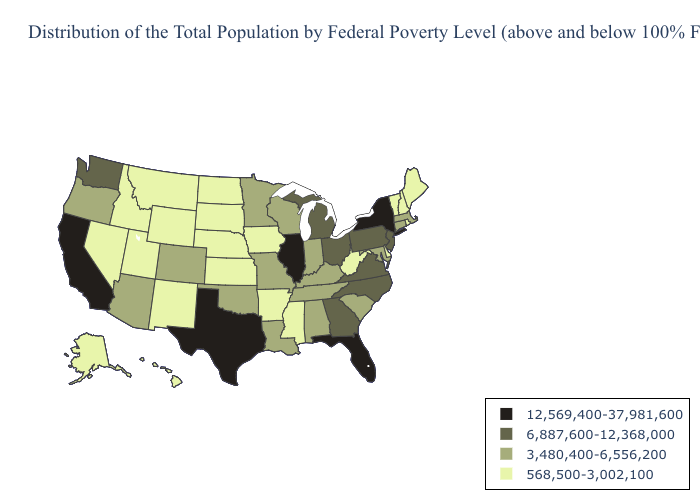What is the highest value in the USA?
Concise answer only. 12,569,400-37,981,600. Name the states that have a value in the range 568,500-3,002,100?
Answer briefly. Alaska, Arkansas, Delaware, Hawaii, Idaho, Iowa, Kansas, Maine, Mississippi, Montana, Nebraska, Nevada, New Hampshire, New Mexico, North Dakota, Rhode Island, South Dakota, Utah, Vermont, West Virginia, Wyoming. Name the states that have a value in the range 6,887,600-12,368,000?
Write a very short answer. Georgia, Michigan, New Jersey, North Carolina, Ohio, Pennsylvania, Virginia, Washington. What is the highest value in the South ?
Concise answer only. 12,569,400-37,981,600. Name the states that have a value in the range 568,500-3,002,100?
Be succinct. Alaska, Arkansas, Delaware, Hawaii, Idaho, Iowa, Kansas, Maine, Mississippi, Montana, Nebraska, Nevada, New Hampshire, New Mexico, North Dakota, Rhode Island, South Dakota, Utah, Vermont, West Virginia, Wyoming. Does New Mexico have the lowest value in the West?
Concise answer only. Yes. Does Arkansas have the highest value in the USA?
Short answer required. No. Name the states that have a value in the range 3,480,400-6,556,200?
Answer briefly. Alabama, Arizona, Colorado, Connecticut, Indiana, Kentucky, Louisiana, Maryland, Massachusetts, Minnesota, Missouri, Oklahoma, Oregon, South Carolina, Tennessee, Wisconsin. Which states have the highest value in the USA?
Answer briefly. California, Florida, Illinois, New York, Texas. Name the states that have a value in the range 3,480,400-6,556,200?
Short answer required. Alabama, Arizona, Colorado, Connecticut, Indiana, Kentucky, Louisiana, Maryland, Massachusetts, Minnesota, Missouri, Oklahoma, Oregon, South Carolina, Tennessee, Wisconsin. Name the states that have a value in the range 6,887,600-12,368,000?
Write a very short answer. Georgia, Michigan, New Jersey, North Carolina, Ohio, Pennsylvania, Virginia, Washington. What is the value of Alaska?
Answer briefly. 568,500-3,002,100. Which states have the lowest value in the USA?
Keep it brief. Alaska, Arkansas, Delaware, Hawaii, Idaho, Iowa, Kansas, Maine, Mississippi, Montana, Nebraska, Nevada, New Hampshire, New Mexico, North Dakota, Rhode Island, South Dakota, Utah, Vermont, West Virginia, Wyoming. What is the highest value in the USA?
Be succinct. 12,569,400-37,981,600. 